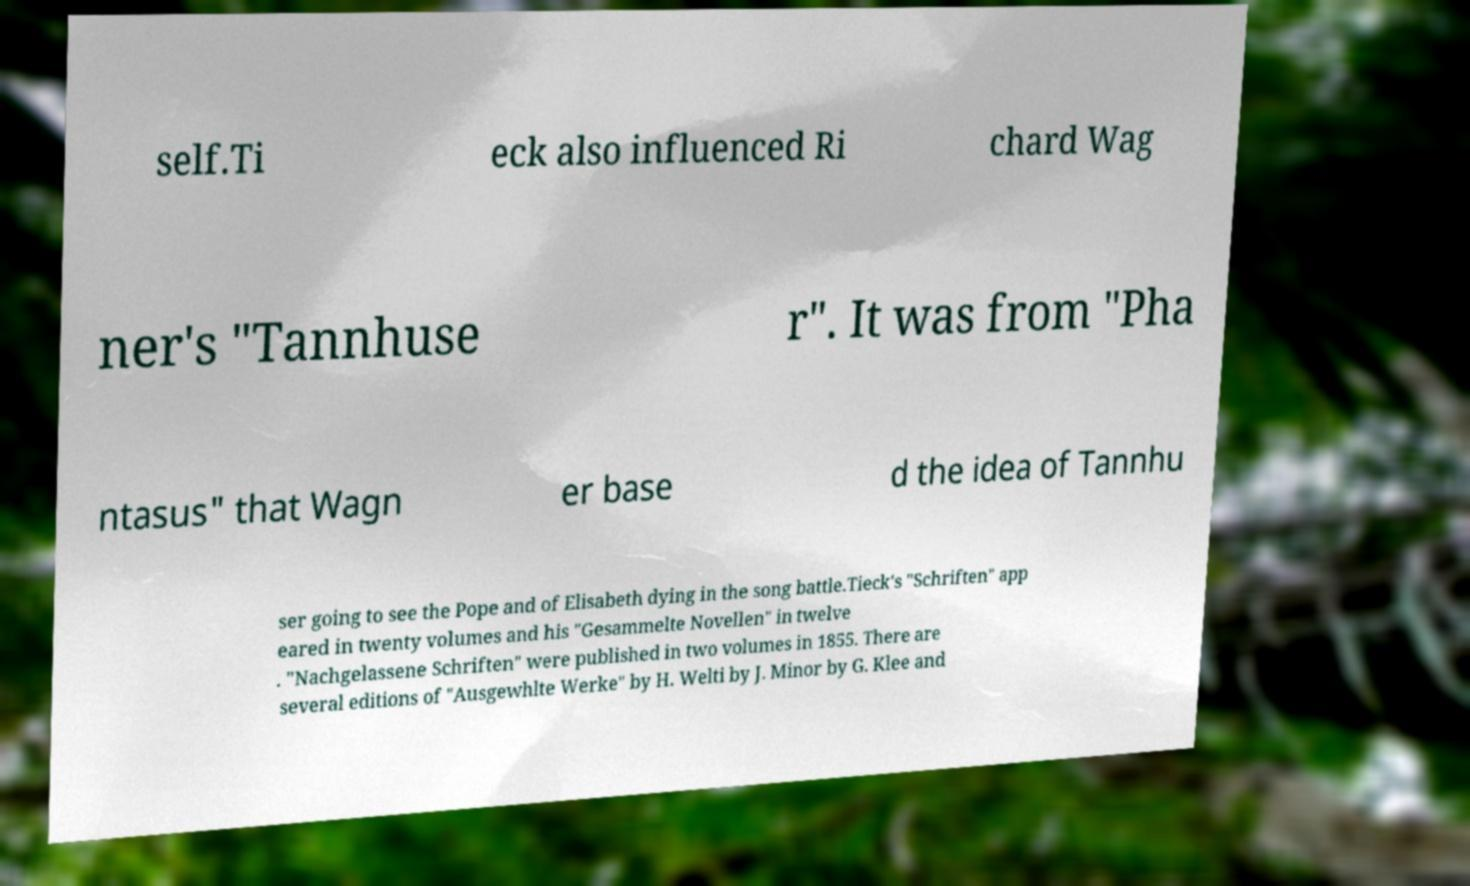Could you extract and type out the text from this image? self.Ti eck also influenced Ri chard Wag ner's "Tannhuse r". It was from "Pha ntasus" that Wagn er base d the idea of Tannhu ser going to see the Pope and of Elisabeth dying in the song battle.Tieck's "Schriften" app eared in twenty volumes and his "Gesammelte Novellen" in twelve . "Nachgelassene Schriften" were published in two volumes in 1855. There are several editions of "Ausgewhlte Werke" by H. Welti by J. Minor by G. Klee and 